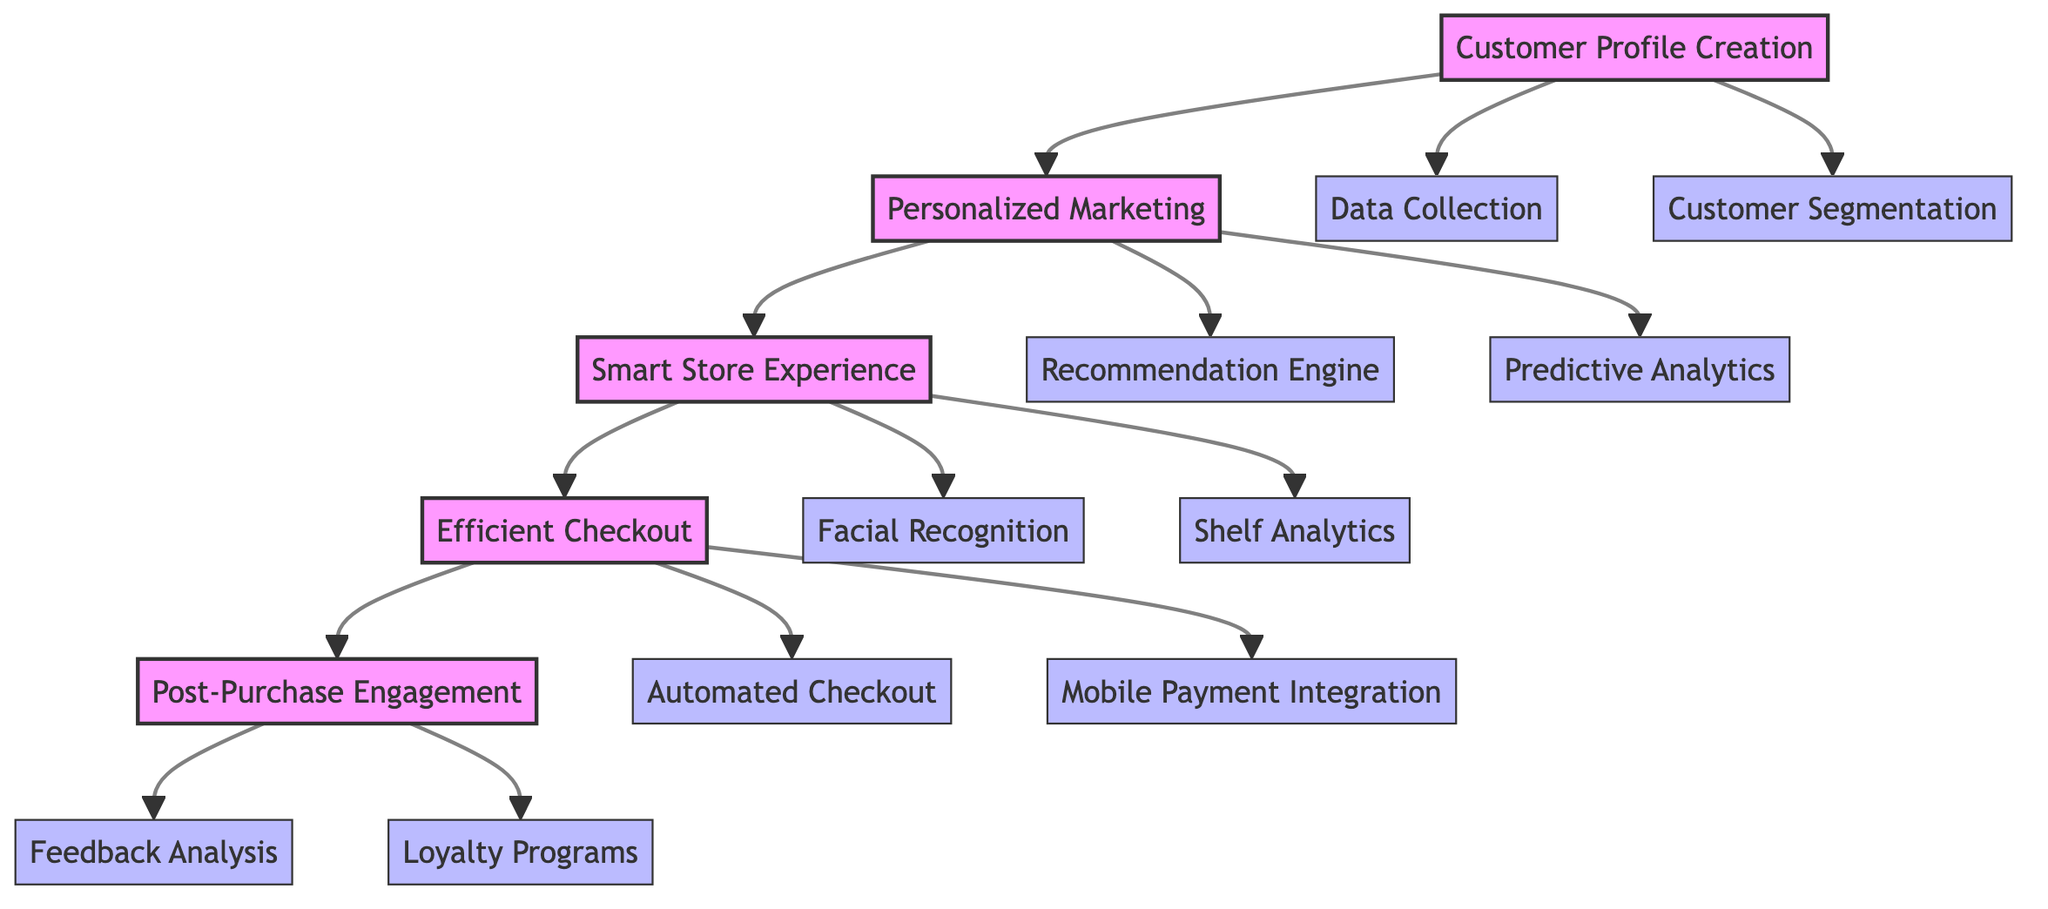What is the first block in the diagram? The diagram starts with "Customer Profile Creation," which is the first block defined in the structured flow.
Answer: Customer Profile Creation How many main blocks are present in the diagram? There are five main blocks in the diagram: Customer Profile Creation, Personalized Marketing, Smart Store Experience, Efficient Checkout, and Post-Purchase Engagement.
Answer: 5 What connects the block "Efficient Checkout" to "Post-Purchase Engagement"? The arrows represent the flow of the customer journey, where "Efficient Checkout" leads directly to "Post-Purchase Engagement" in a sequential manner.
Answer: Direct connection Which component describes the streamlining of the purchase process? The component "Automated Checkout" directly relates to the description of streamlining the purchase process under the block "Efficient Checkout."
Answer: Automated Checkout What type of analytics does the "Personalized Marketing" block utilize to predict customer behavior? The block "Personalized Marketing" utilizes "Predictive Analytics" as its component to analyze past data and predict future customer behavior.
Answer: Predictive Analytics How many components are related to the "Smart Store Experience" block? There are two components under the "Smart Store Experience" block: "Facial Recognition" and "Shelf Analytics." This counts to two components in total.
Answer: 2 What is the relationship between "Recommendation Engine" and "Customer Profile Creation"? The "Recommendation Engine" is located under the "Personalized Marketing" block, which follows the "Customer Profile Creation," indicating the flow from understanding customers to providing personalized marketing strategies.
Answer: Sequential relationship Which block focuses on customer loyalty and satisfaction after a purchase? The block titled "Post-Purchase Engagement" specifically emphasizes maintaining customer loyalty and satisfaction after the purchase process has been completed.
Answer: Post-Purchase Engagement What method does the "Feedback Analysis" component use? The "Feedback Analysis" component employs natural language processing to analyze customer feedback effectively.
Answer: Natural language processing 